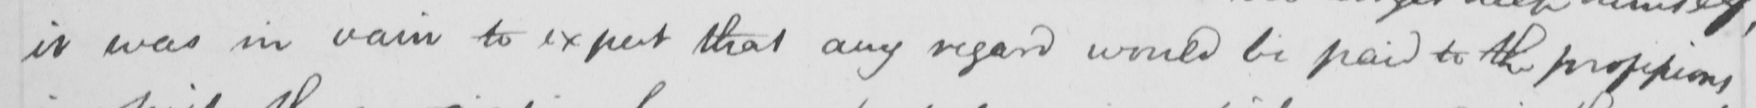Please transcribe the handwritten text in this image. it was in vain to expect that any regard would be paid to the professions 